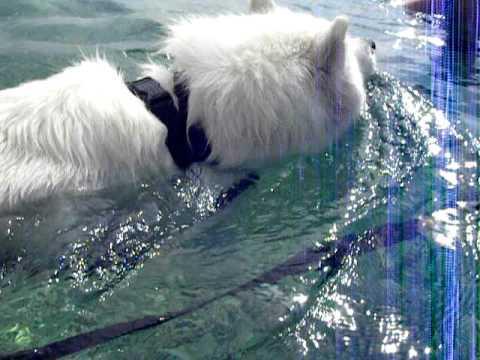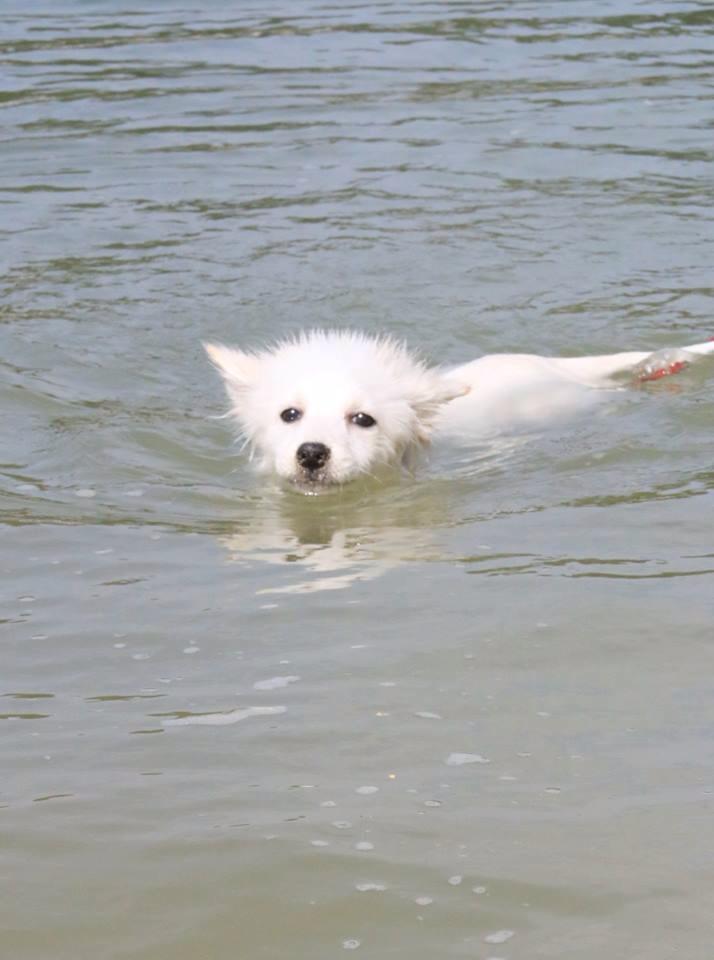The first image is the image on the left, the second image is the image on the right. Given the left and right images, does the statement "In at least one image, a white dog is seen swimming in water" hold true? Answer yes or no. Yes. The first image is the image on the left, the second image is the image on the right. Evaluate the accuracy of this statement regarding the images: "The left image contains a white dog swimming in water.". Is it true? Answer yes or no. Yes. 